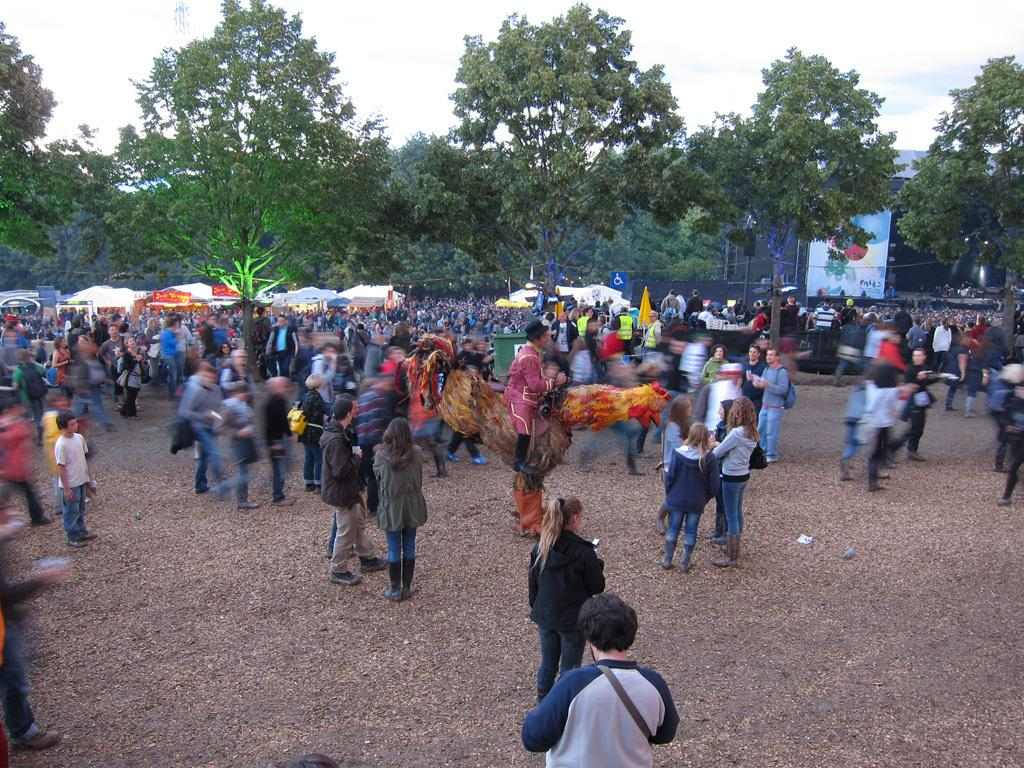What are the people in the image doing? There is a group of people standing on the ground in the image. What can be seen in the background of the image? There are trees and the sky visible in the background of the image. What object is located on the right side of the image? There is a board on the right side of the image. How many legs does the yoke have in the image? There is no yoke present in the image. What is the profit of the people standing in the image? The image does not provide information about the people's profit. 